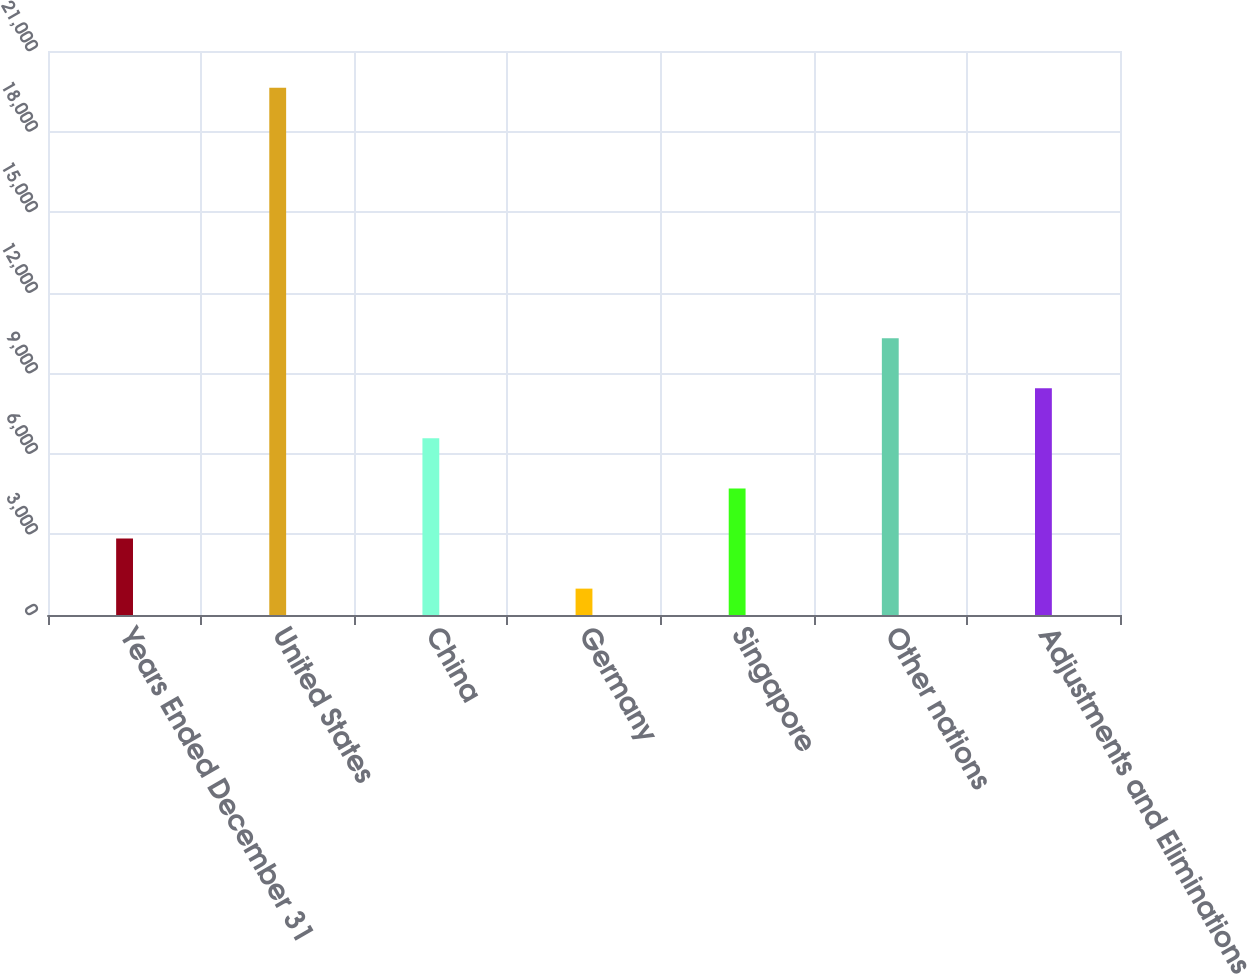<chart> <loc_0><loc_0><loc_500><loc_500><bar_chart><fcel>Years Ended December 31<fcel>United States<fcel>China<fcel>Germany<fcel>Singapore<fcel>Other nations<fcel>Adjustments and Eliminations<nl><fcel>2847.1<fcel>19633<fcel>6577.3<fcel>982<fcel>4712.2<fcel>10307.5<fcel>8442.4<nl></chart> 